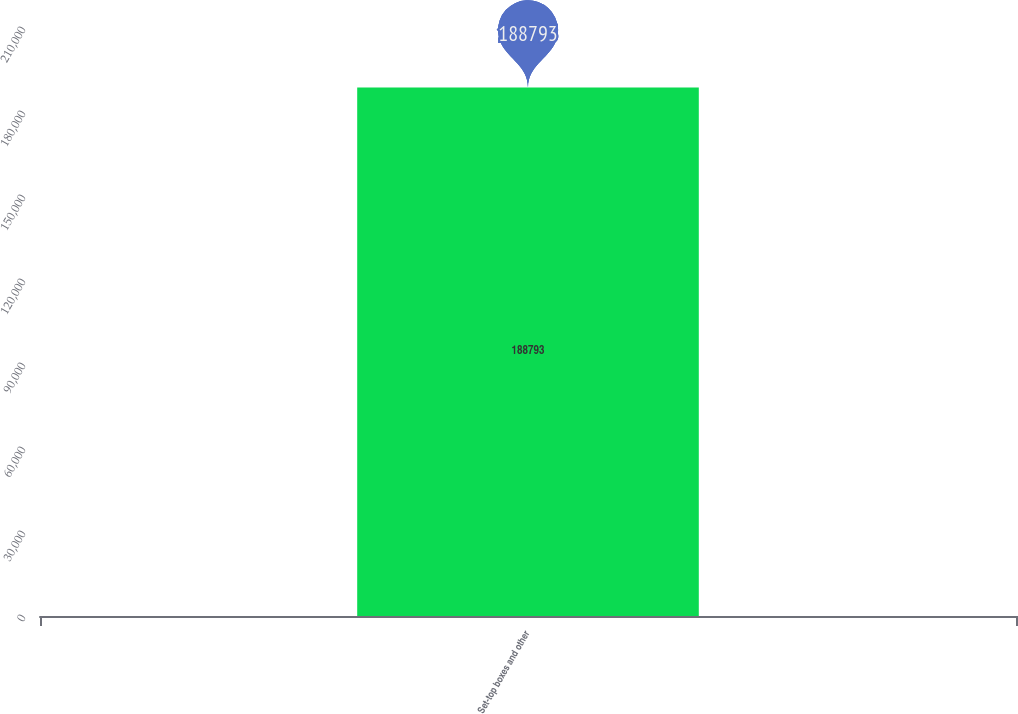Convert chart. <chart><loc_0><loc_0><loc_500><loc_500><bar_chart><fcel>Set-top boxes and other<nl><fcel>188793<nl></chart> 